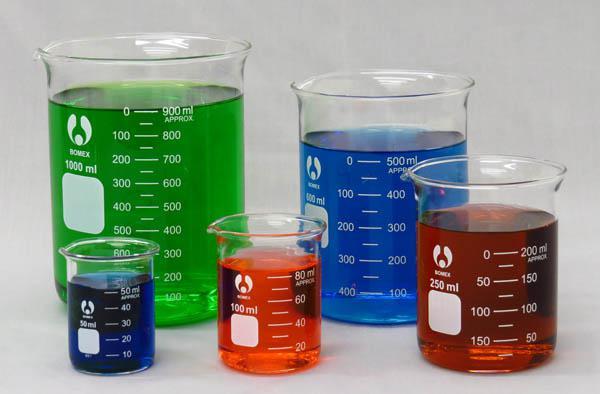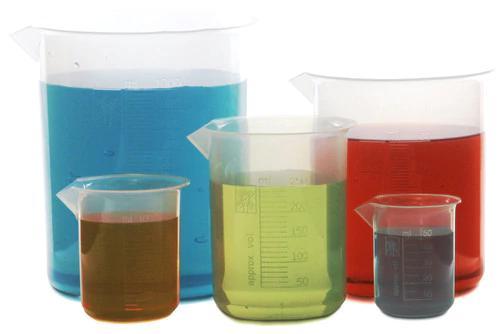The first image is the image on the left, the second image is the image on the right. Given the left and right images, does the statement "Every photo shows five containers of colored liquid with two large containers in the back and three small containers in the front." hold true? Answer yes or no. Yes. The first image is the image on the left, the second image is the image on the right. Assess this claim about the two images: "The left and right image contains the same number of filled beckers.". Correct or not? Answer yes or no. Yes. 